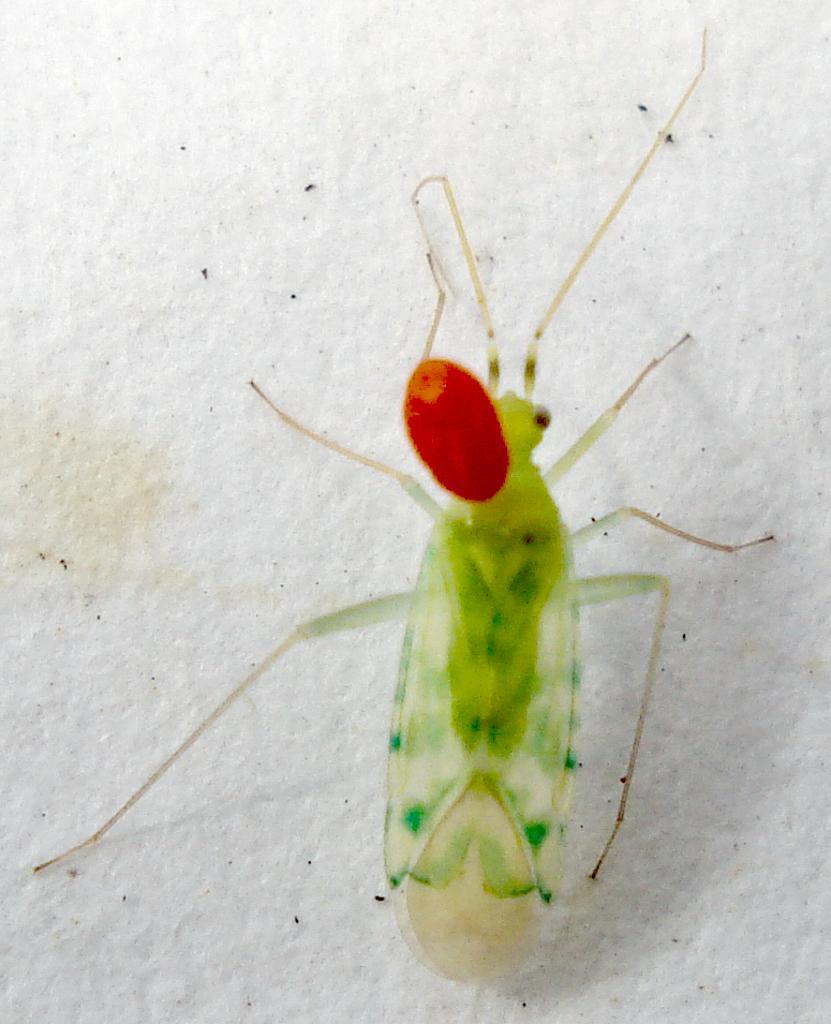In one or two sentences, can you explain what this image depicts? In this image I can see a cicada. 